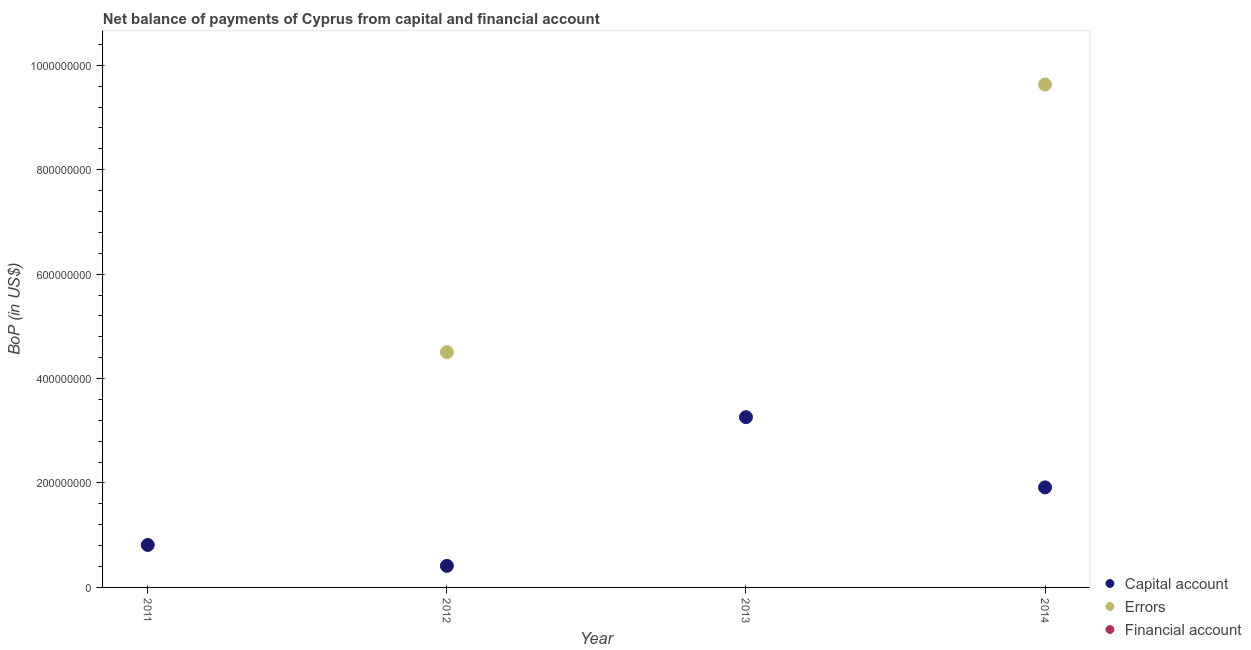How many different coloured dotlines are there?
Offer a very short reply. 2. Is the number of dotlines equal to the number of legend labels?
Ensure brevity in your answer.  No. What is the amount of net capital account in 2011?
Give a very brief answer. 8.13e+07. Across all years, what is the maximum amount of net capital account?
Your answer should be very brief. 3.26e+08. Across all years, what is the minimum amount of net capital account?
Offer a terse response. 4.13e+07. In which year was the amount of net capital account maximum?
Your answer should be very brief. 2013. What is the total amount of net capital account in the graph?
Your answer should be very brief. 6.40e+08. What is the difference between the amount of net capital account in 2012 and that in 2013?
Give a very brief answer. -2.85e+08. What is the difference between the amount of net capital account in 2014 and the amount of errors in 2012?
Your answer should be very brief. -2.59e+08. What is the average amount of net capital account per year?
Keep it short and to the point. 1.60e+08. In the year 2012, what is the difference between the amount of net capital account and amount of errors?
Your answer should be very brief. -4.09e+08. What is the ratio of the amount of net capital account in 2013 to that in 2014?
Your response must be concise. 1.7. Is the difference between the amount of net capital account in 2012 and 2014 greater than the difference between the amount of errors in 2012 and 2014?
Offer a terse response. Yes. What is the difference between the highest and the second highest amount of net capital account?
Keep it short and to the point. 1.34e+08. What is the difference between the highest and the lowest amount of errors?
Offer a terse response. 9.63e+08. In how many years, is the amount of errors greater than the average amount of errors taken over all years?
Provide a short and direct response. 2. Is the sum of the amount of net capital account in 2011 and 2012 greater than the maximum amount of financial account across all years?
Offer a very short reply. Yes. Is the amount of net capital account strictly less than the amount of financial account over the years?
Your answer should be very brief. No. How many dotlines are there?
Make the answer very short. 2. Are the values on the major ticks of Y-axis written in scientific E-notation?
Make the answer very short. No. Does the graph contain any zero values?
Offer a terse response. Yes. What is the title of the graph?
Provide a short and direct response. Net balance of payments of Cyprus from capital and financial account. Does "Taxes" appear as one of the legend labels in the graph?
Provide a succinct answer. No. What is the label or title of the Y-axis?
Provide a succinct answer. BoP (in US$). What is the BoP (in US$) of Capital account in 2011?
Your answer should be compact. 8.13e+07. What is the BoP (in US$) in Errors in 2011?
Make the answer very short. 0. What is the BoP (in US$) in Capital account in 2012?
Ensure brevity in your answer.  4.13e+07. What is the BoP (in US$) of Errors in 2012?
Your answer should be compact. 4.51e+08. What is the BoP (in US$) in Financial account in 2012?
Your response must be concise. 0. What is the BoP (in US$) of Capital account in 2013?
Your response must be concise. 3.26e+08. What is the BoP (in US$) in Capital account in 2014?
Give a very brief answer. 1.92e+08. What is the BoP (in US$) of Errors in 2014?
Ensure brevity in your answer.  9.63e+08. Across all years, what is the maximum BoP (in US$) in Capital account?
Provide a succinct answer. 3.26e+08. Across all years, what is the maximum BoP (in US$) in Errors?
Ensure brevity in your answer.  9.63e+08. Across all years, what is the minimum BoP (in US$) of Capital account?
Your answer should be compact. 4.13e+07. Across all years, what is the minimum BoP (in US$) of Errors?
Provide a succinct answer. 0. What is the total BoP (in US$) of Capital account in the graph?
Ensure brevity in your answer.  6.40e+08. What is the total BoP (in US$) in Errors in the graph?
Offer a very short reply. 1.41e+09. What is the total BoP (in US$) of Financial account in the graph?
Your answer should be compact. 0. What is the difference between the BoP (in US$) in Capital account in 2011 and that in 2012?
Your response must be concise. 4.01e+07. What is the difference between the BoP (in US$) of Capital account in 2011 and that in 2013?
Provide a short and direct response. -2.45e+08. What is the difference between the BoP (in US$) of Capital account in 2011 and that in 2014?
Ensure brevity in your answer.  -1.10e+08. What is the difference between the BoP (in US$) in Capital account in 2012 and that in 2013?
Give a very brief answer. -2.85e+08. What is the difference between the BoP (in US$) in Capital account in 2012 and that in 2014?
Your answer should be compact. -1.50e+08. What is the difference between the BoP (in US$) in Errors in 2012 and that in 2014?
Provide a short and direct response. -5.12e+08. What is the difference between the BoP (in US$) in Capital account in 2013 and that in 2014?
Your answer should be very brief. 1.34e+08. What is the difference between the BoP (in US$) in Capital account in 2011 and the BoP (in US$) in Errors in 2012?
Offer a very short reply. -3.69e+08. What is the difference between the BoP (in US$) in Capital account in 2011 and the BoP (in US$) in Errors in 2014?
Provide a short and direct response. -8.82e+08. What is the difference between the BoP (in US$) in Capital account in 2012 and the BoP (in US$) in Errors in 2014?
Provide a short and direct response. -9.22e+08. What is the difference between the BoP (in US$) of Capital account in 2013 and the BoP (in US$) of Errors in 2014?
Provide a succinct answer. -6.37e+08. What is the average BoP (in US$) in Capital account per year?
Keep it short and to the point. 1.60e+08. What is the average BoP (in US$) in Errors per year?
Ensure brevity in your answer.  3.53e+08. What is the average BoP (in US$) in Financial account per year?
Provide a succinct answer. 0. In the year 2012, what is the difference between the BoP (in US$) in Capital account and BoP (in US$) in Errors?
Offer a terse response. -4.09e+08. In the year 2014, what is the difference between the BoP (in US$) in Capital account and BoP (in US$) in Errors?
Provide a succinct answer. -7.72e+08. What is the ratio of the BoP (in US$) of Capital account in 2011 to that in 2012?
Keep it short and to the point. 1.97. What is the ratio of the BoP (in US$) of Capital account in 2011 to that in 2013?
Provide a succinct answer. 0.25. What is the ratio of the BoP (in US$) of Capital account in 2011 to that in 2014?
Keep it short and to the point. 0.42. What is the ratio of the BoP (in US$) of Capital account in 2012 to that in 2013?
Ensure brevity in your answer.  0.13. What is the ratio of the BoP (in US$) in Capital account in 2012 to that in 2014?
Make the answer very short. 0.22. What is the ratio of the BoP (in US$) in Errors in 2012 to that in 2014?
Keep it short and to the point. 0.47. What is the ratio of the BoP (in US$) in Capital account in 2013 to that in 2014?
Provide a succinct answer. 1.7. What is the difference between the highest and the second highest BoP (in US$) of Capital account?
Provide a short and direct response. 1.34e+08. What is the difference between the highest and the lowest BoP (in US$) in Capital account?
Your answer should be very brief. 2.85e+08. What is the difference between the highest and the lowest BoP (in US$) in Errors?
Offer a terse response. 9.63e+08. 